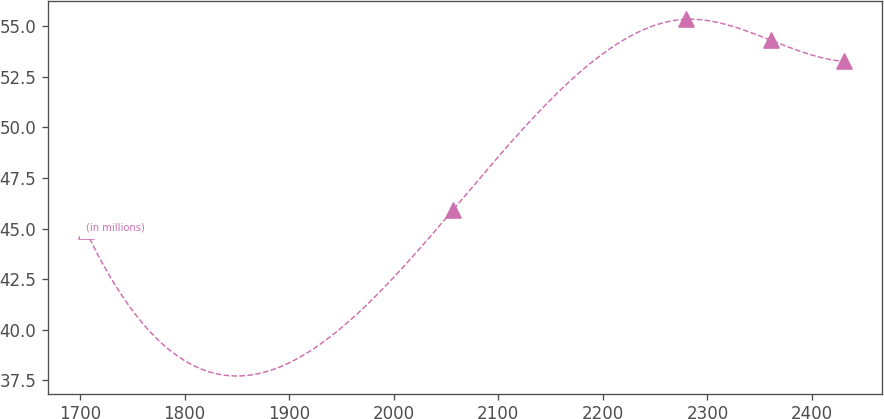Convert chart. <chart><loc_0><loc_0><loc_500><loc_500><line_chart><ecel><fcel>(in millions)<nl><fcel>1705.79<fcel>44.87<nl><fcel>2056.49<fcel>45.91<nl><fcel>2279.06<fcel>55.34<nl><fcel>2360.9<fcel>54.3<nl><fcel>2430.66<fcel>53.26<nl></chart> 